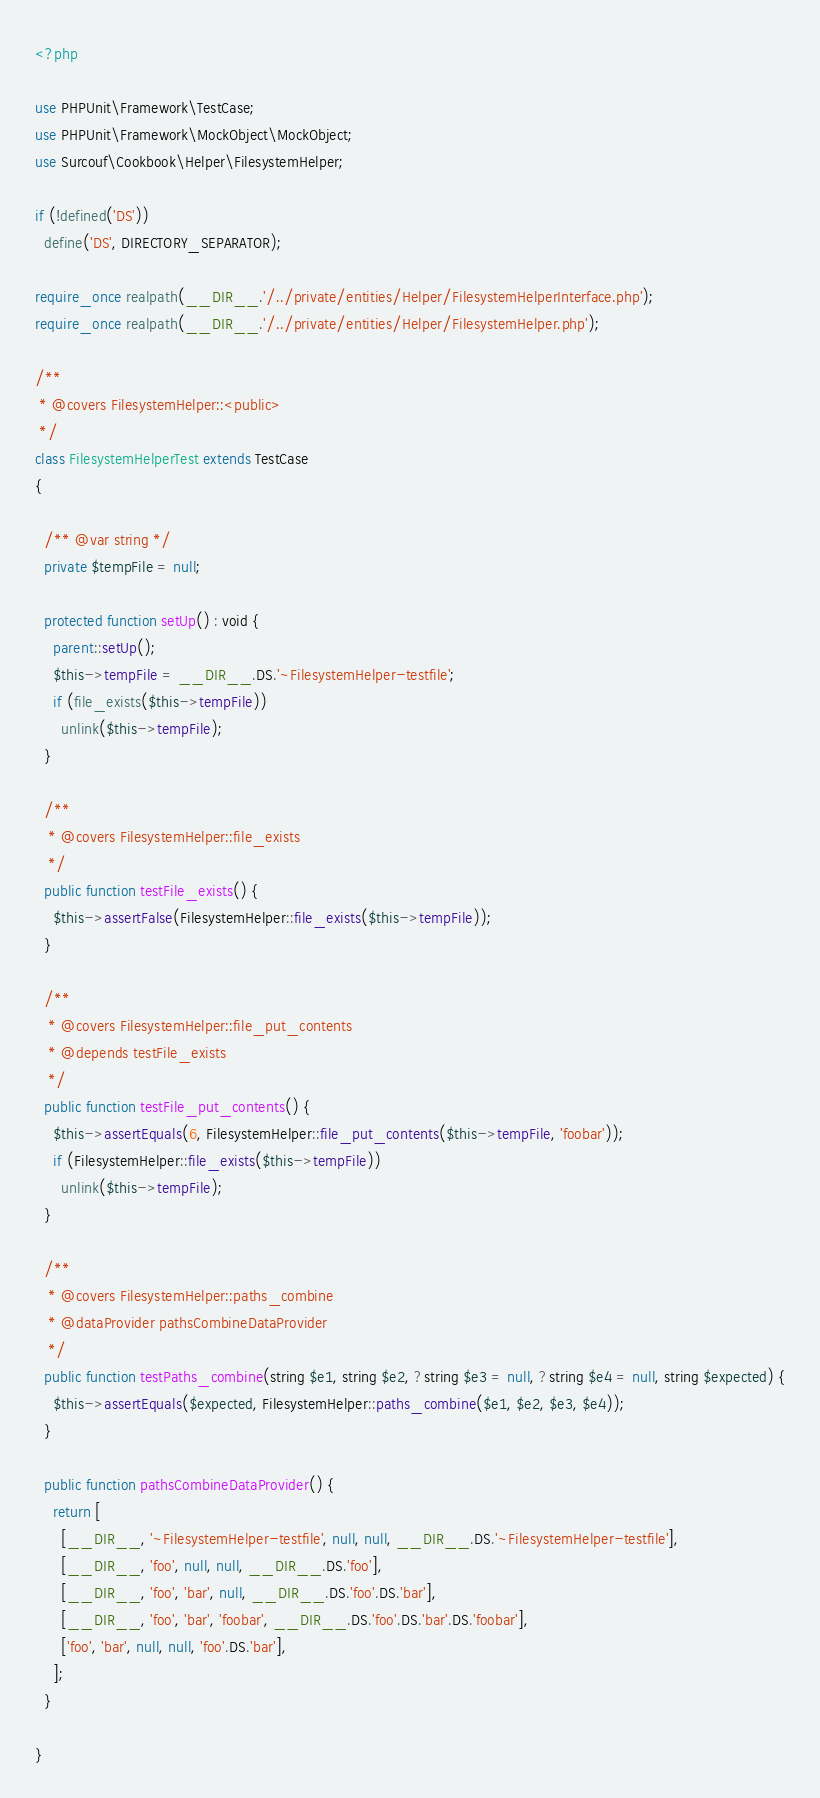Convert code to text. <code><loc_0><loc_0><loc_500><loc_500><_PHP_><?php

use PHPUnit\Framework\TestCase;
use PHPUnit\Framework\MockObject\MockObject;
use Surcouf\Cookbook\Helper\FilesystemHelper;

if (!defined('DS'))
  define('DS', DIRECTORY_SEPARATOR);

require_once realpath(__DIR__.'/../private/entities/Helper/FilesystemHelperInterface.php');
require_once realpath(__DIR__.'/../private/entities/Helper/FilesystemHelper.php');

/**
 * @covers FilesystemHelper::<public>
 */
class FilesystemHelperTest extends TestCase
{

  /** @var string */
  private $tempFile = null;

  protected function setUp() : void {
    parent::setUp();
    $this->tempFile = __DIR__.DS.'~FilesystemHelper-testfile';
    if (file_exists($this->tempFile))
      unlink($this->tempFile);
  }

  /**
   * @covers FilesystemHelper::file_exists
   */
  public function testFile_exists() {
    $this->assertFalse(FilesystemHelper::file_exists($this->tempFile));
  }

  /**
   * @covers FilesystemHelper::file_put_contents
   * @depends testFile_exists
   */
  public function testFile_put_contents() {
    $this->assertEquals(6, FilesystemHelper::file_put_contents($this->tempFile, 'foobar'));
    if (FilesystemHelper::file_exists($this->tempFile))
      unlink($this->tempFile);
  }

  /**
   * @covers FilesystemHelper::paths_combine
   * @dataProvider pathsCombineDataProvider
   */
  public function testPaths_combine(string $e1, string $e2, ?string $e3 = null, ?string $e4 = null, string $expected) {
    $this->assertEquals($expected, FilesystemHelper::paths_combine($e1, $e2, $e3, $e4));
  }

  public function pathsCombineDataProvider() {
    return [
      [__DIR__, '~FilesystemHelper-testfile', null, null, __DIR__.DS.'~FilesystemHelper-testfile'],
      [__DIR__, 'foo', null, null, __DIR__.DS.'foo'],
      [__DIR__, 'foo', 'bar', null, __DIR__.DS.'foo'.DS.'bar'],
      [__DIR__, 'foo', 'bar', 'foobar', __DIR__.DS.'foo'.DS.'bar'.DS.'foobar'],
      ['foo', 'bar', null, null, 'foo'.DS.'bar'],
    ];
  }

}
</code> 